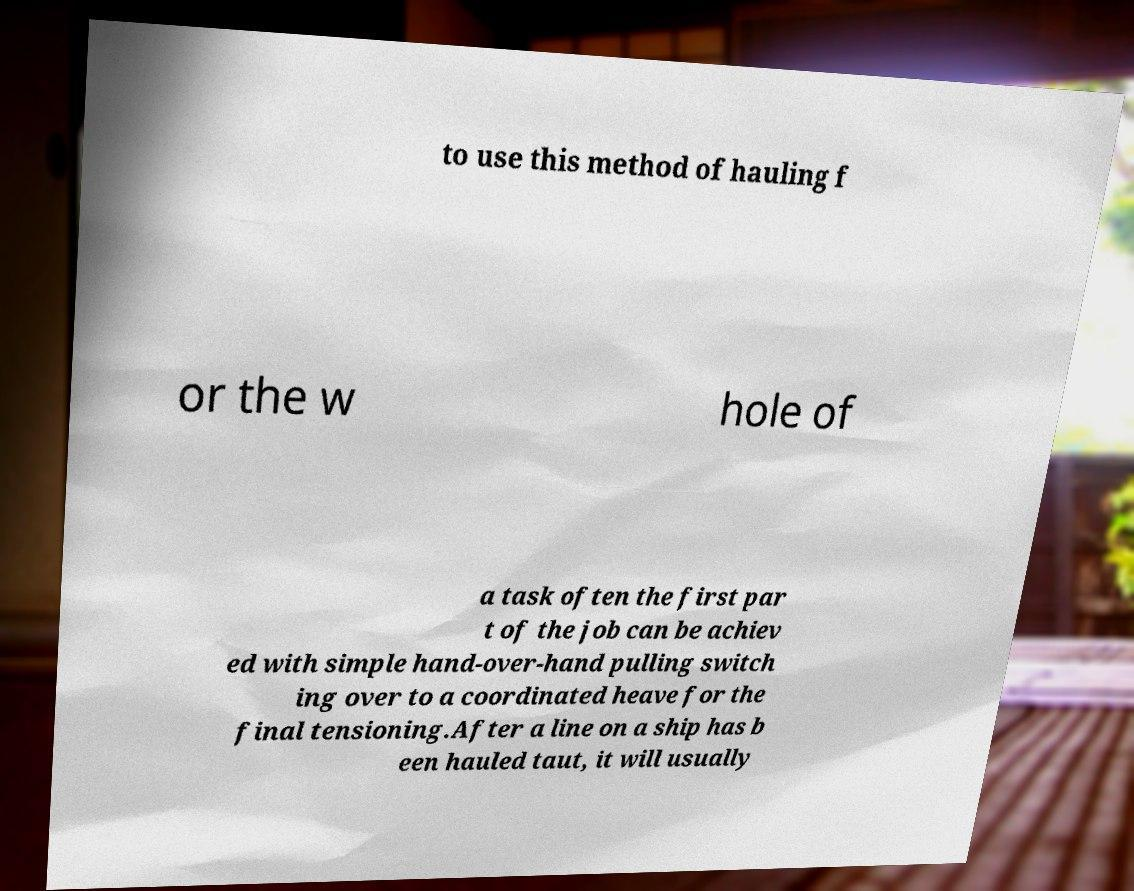Could you extract and type out the text from this image? to use this method of hauling f or the w hole of a task often the first par t of the job can be achiev ed with simple hand-over-hand pulling switch ing over to a coordinated heave for the final tensioning.After a line on a ship has b een hauled taut, it will usually 